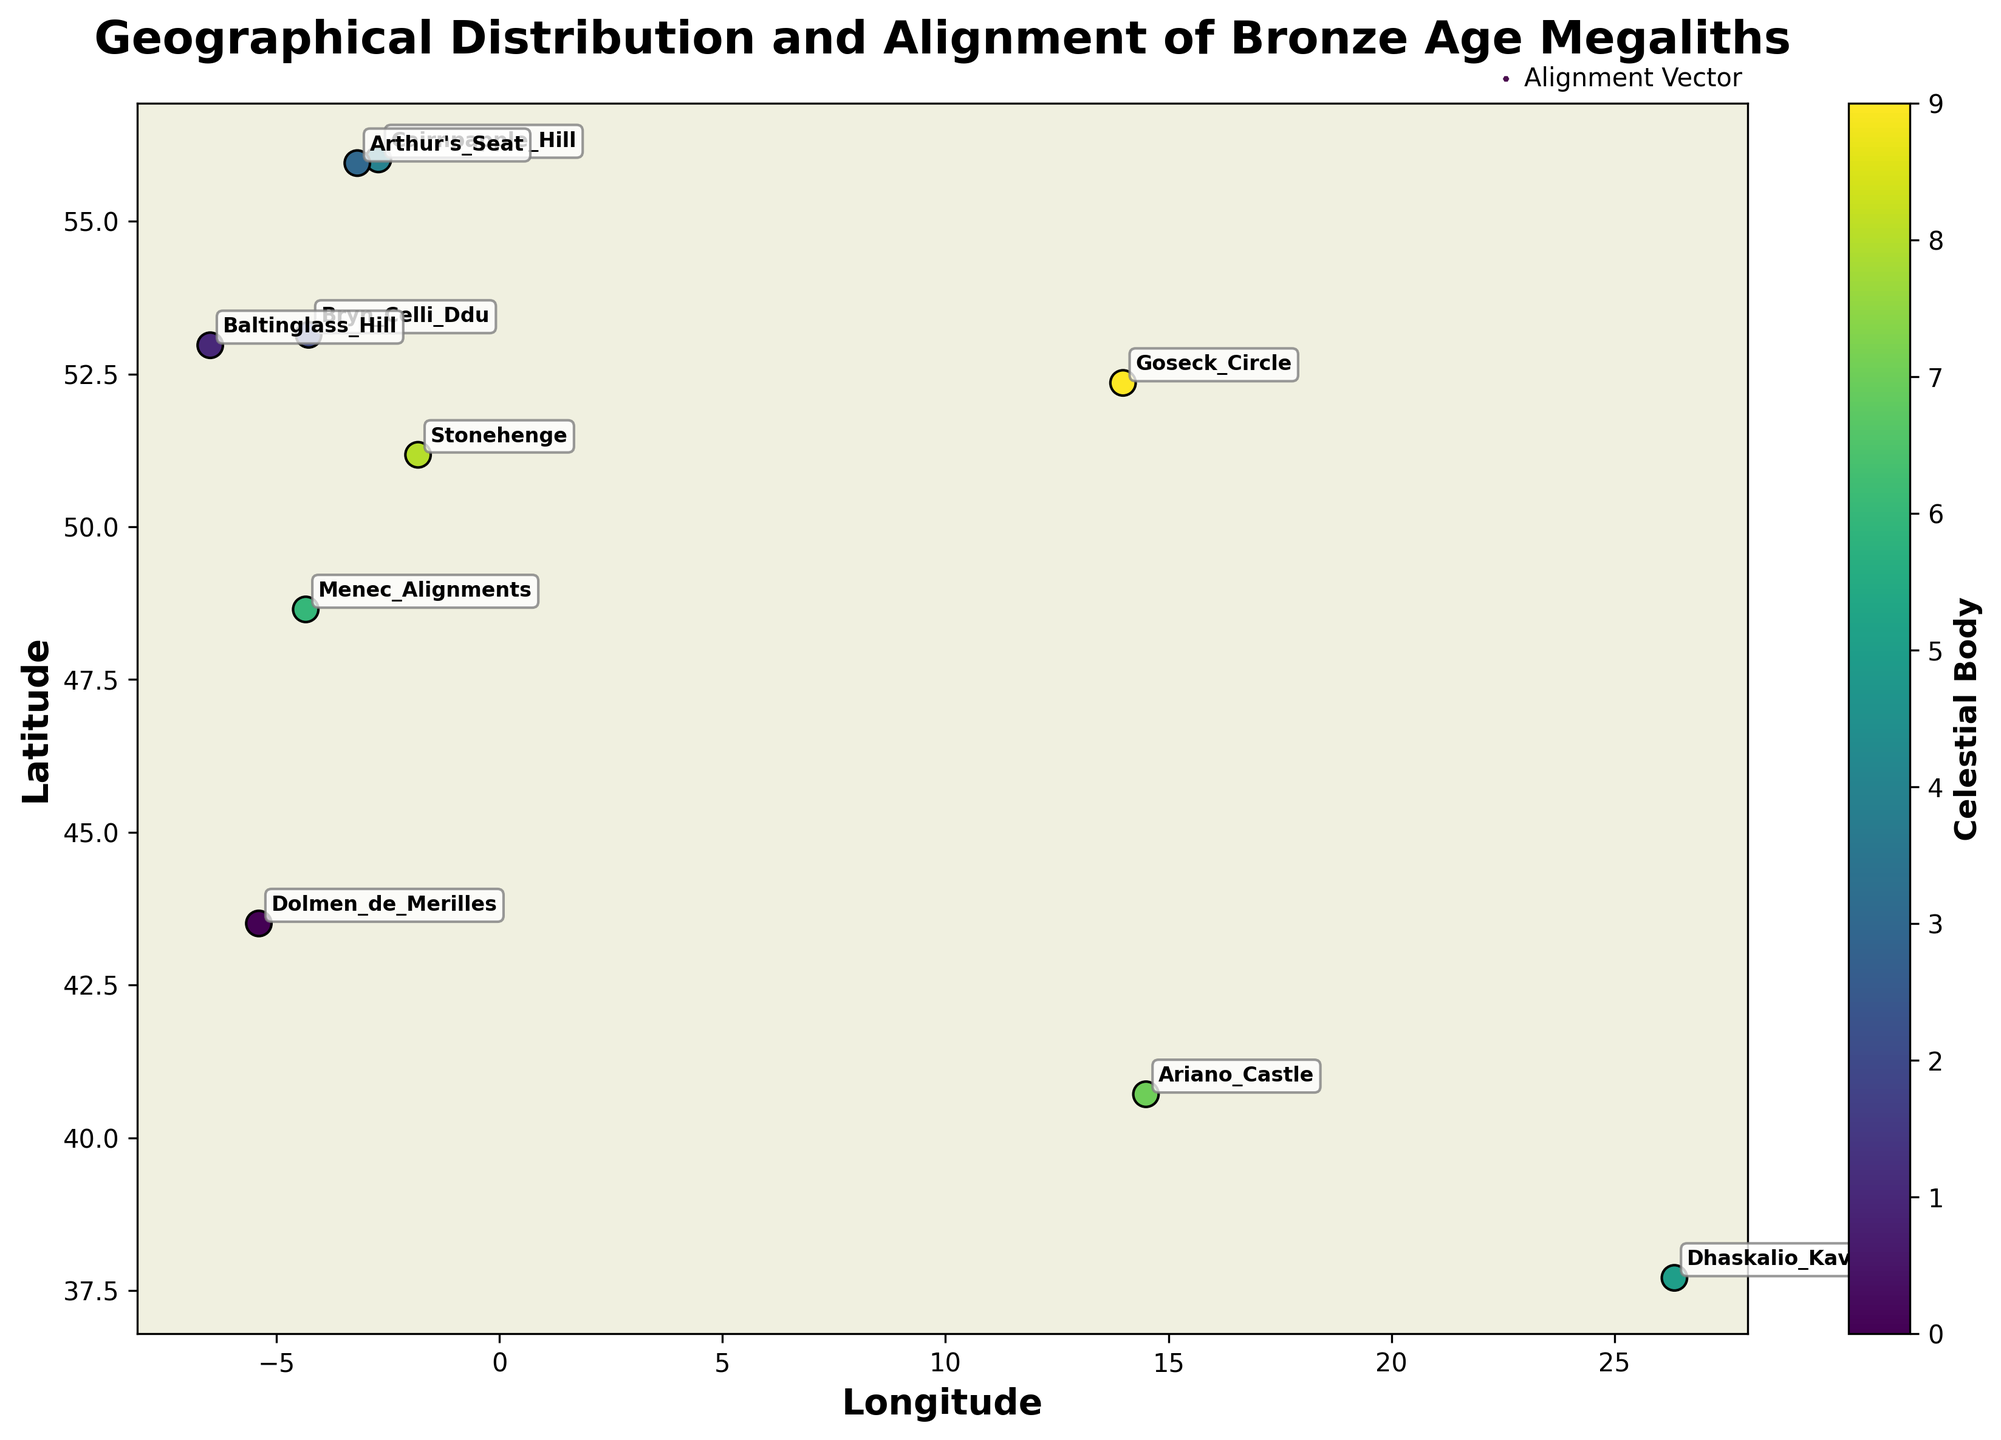Which site is aligned with Orion's Belt? We find the vector with `Celestial_Body` labeled as "Orion's Belt" and locate the corresponding `Site_Name`.
Answer: Dhaskalio Kavos What is the longitude of Stonehenge? Locate the `Longitude` value for the row where `Site_Name` is "Stonehenge".
Answer: -1.8262 Which celestial body is the most common for the megalith sites? Identify the `Celestial_Body` with the most occurrences in the scatter plot.
Answer: Midwinter Sunrise Which site is located furthest north? Compare the `Latitude` values of all the sites and find the maximum.
Answer: Cairnpapple Hill What colors are used to represent the different celestial bodies? Observe the scatter plot to identify distinct colors and their corresponding celestial bodies from the color bar.
Answer: Various colors, including shades of blue, green, and yellow Which site's alignment vector points the most northward? Identify the vector with the greatest `Alignment_Y` value.
Answer: Menec Alignments Are there any sites whose alignment vectors point primarily southward? Check for vectors with negative `Alignment_Y` values.
Answer: Yes, Cairnpapple Hill and Dolmen de Merilles What is the general trend in the orientation of sites located above 50° latitude? Observe the direction of vectors (arrows) in the northern section of the plot (i.e., above 50° latitude).
Answer: Most vectors point towards the northeast or southeast How does the alignment vector for Goseck Circle compare to that of Arthur's Seat? Compare the `Alignment_X` and `Alignment_Y` values for "Goseck Circle" and "Arthur's Seat".
Answer: Goseck Circle: (0.766, -0.643), Arthur's Seat: (0.5, -0.866) Between which latitudes are most of the sites located? Observe the distribution of latitude values and find the range with the most data points.
Answer: 50° to 55° 